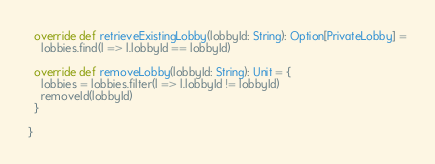<code> <loc_0><loc_0><loc_500><loc_500><_Scala_>  override def retrieveExistingLobby(lobbyId: String): Option[PrivateLobby] =
    lobbies.find(l => l.lobbyId == lobbyId)

  override def removeLobby(lobbyId: String): Unit = {
    lobbies = lobbies.filter(l => l.lobbyId != lobbyId)
    removeId(lobbyId)
  }

}


</code> 